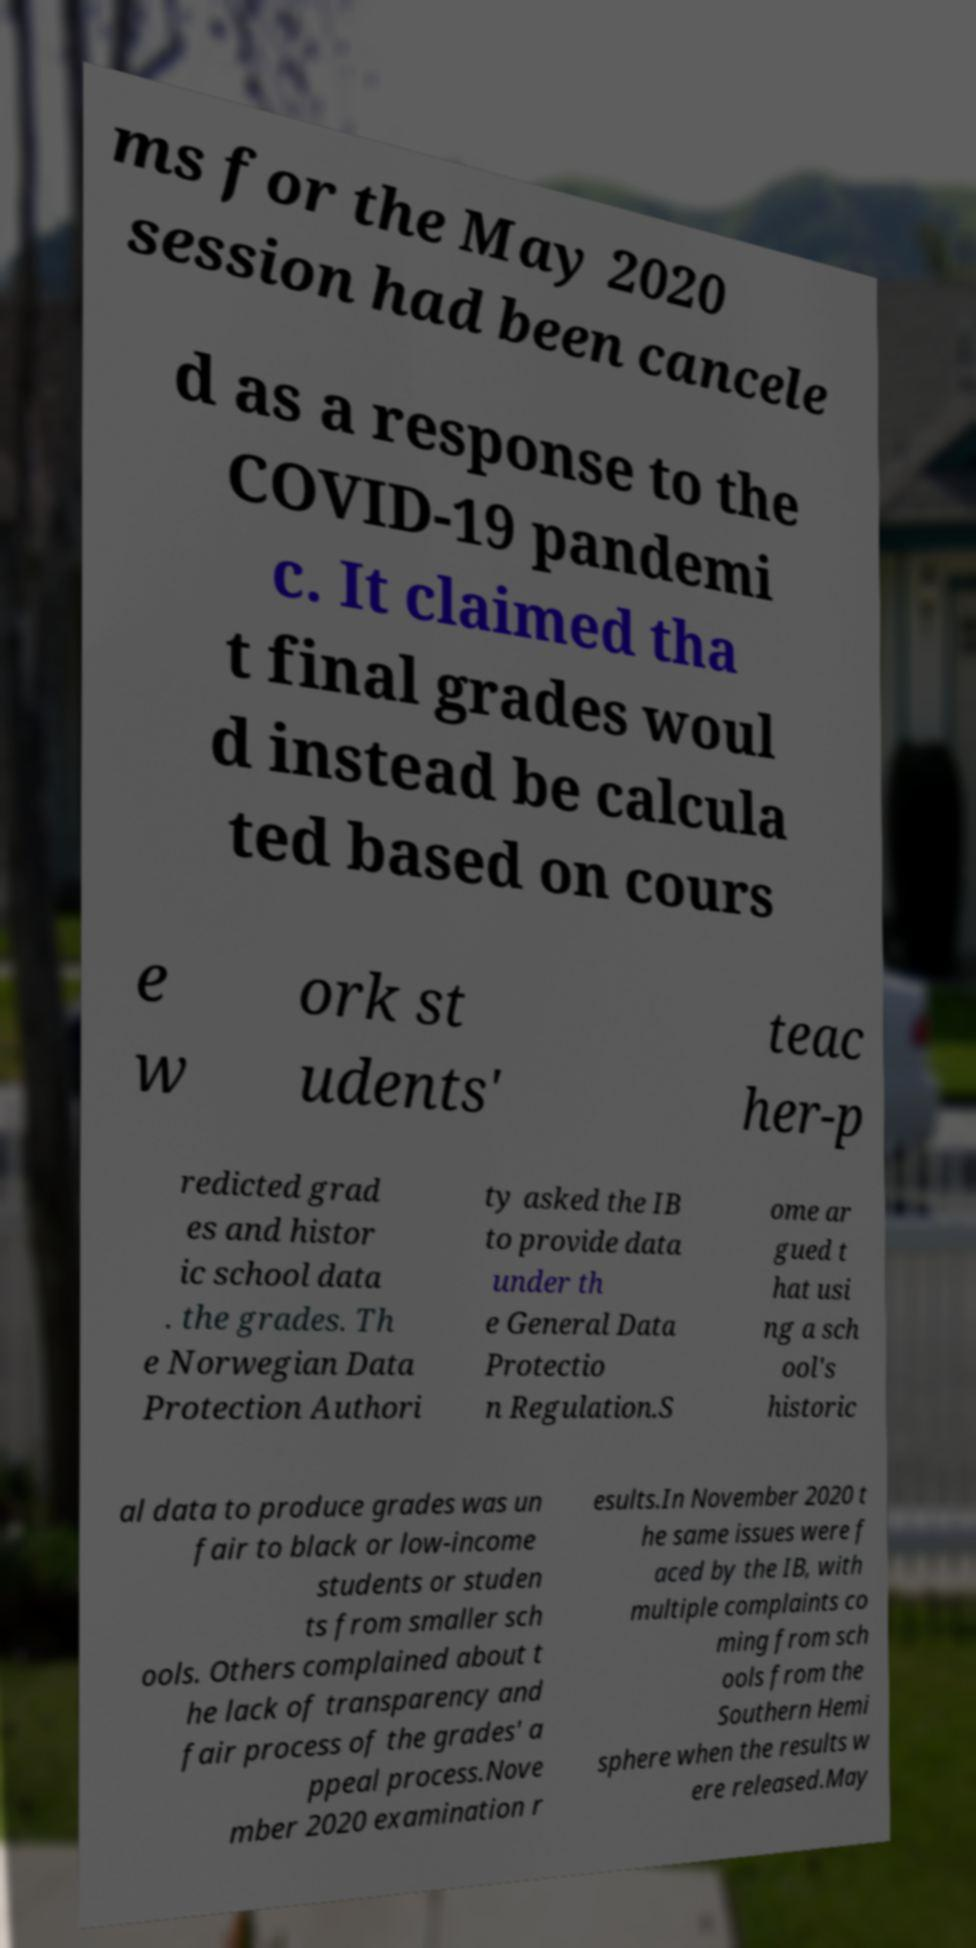I need the written content from this picture converted into text. Can you do that? ms for the May 2020 session had been cancele d as a response to the COVID-19 pandemi c. It claimed tha t final grades woul d instead be calcula ted based on cours e w ork st udents' teac her-p redicted grad es and histor ic school data . the grades. Th e Norwegian Data Protection Authori ty asked the IB to provide data under th e General Data Protectio n Regulation.S ome ar gued t hat usi ng a sch ool's historic al data to produce grades was un fair to black or low-income students or studen ts from smaller sch ools. Others complained about t he lack of transparency and fair process of the grades' a ppeal process.Nove mber 2020 examination r esults.In November 2020 t he same issues were f aced by the IB, with multiple complaints co ming from sch ools from the Southern Hemi sphere when the results w ere released.May 